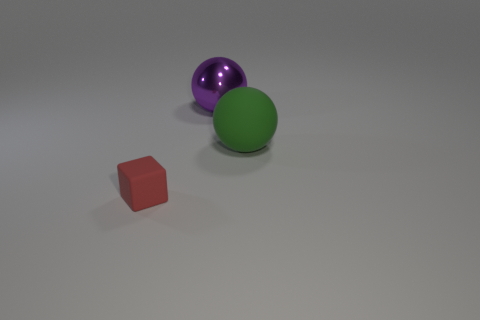There is a matte thing behind the red cube; is its size the same as the purple sphere?
Give a very brief answer. Yes. Is the number of small blocks that are left of the cube the same as the number of purple shiny balls?
Keep it short and to the point. No. How many objects are either objects right of the red object or big purple metallic objects?
Give a very brief answer. 2. The object that is to the right of the cube and to the left of the green object has what shape?
Your answer should be compact. Sphere. How many things are either tiny things that are in front of the big shiny thing or spheres that are behind the large green rubber thing?
Ensure brevity in your answer.  2. What number of other things are the same size as the green ball?
Provide a succinct answer. 1. Is the color of the big sphere that is in front of the purple thing the same as the small matte thing?
Your response must be concise. No. What size is the object that is both on the right side of the tiny thing and to the left of the green matte object?
Offer a very short reply. Large. What number of tiny objects are either red shiny things or matte things?
Give a very brief answer. 1. What shape is the thing on the left side of the purple thing?
Keep it short and to the point. Cube. 